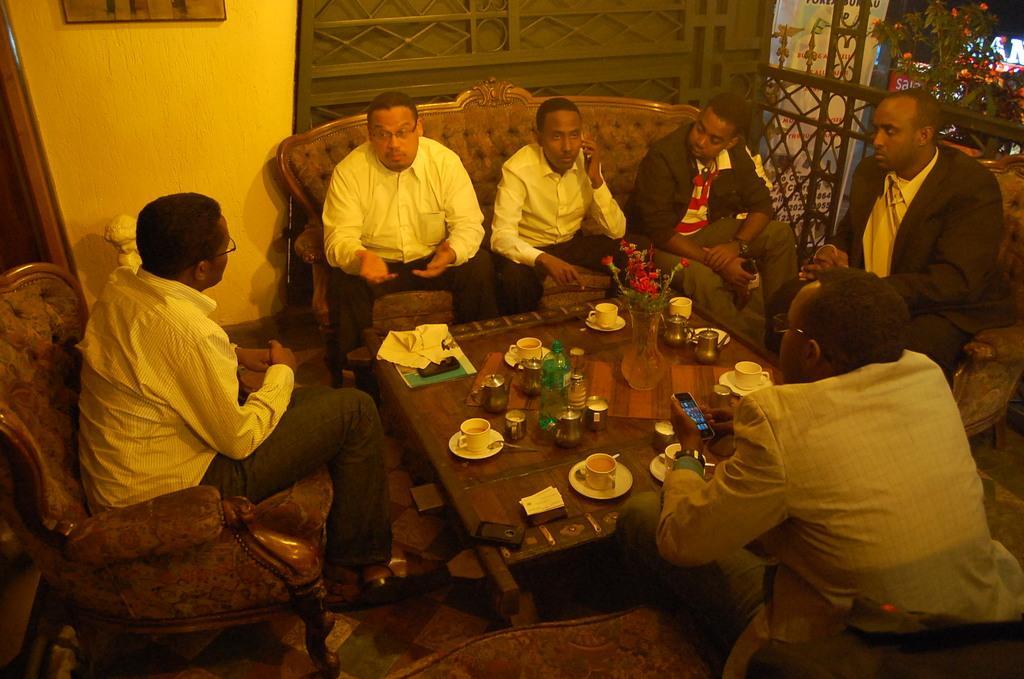In one or two sentences, can you explain what this image depicts? In this image we have few persons sitting on the couch and chair in front of the glass table. On the table we have few cup teas and other stuff on it 